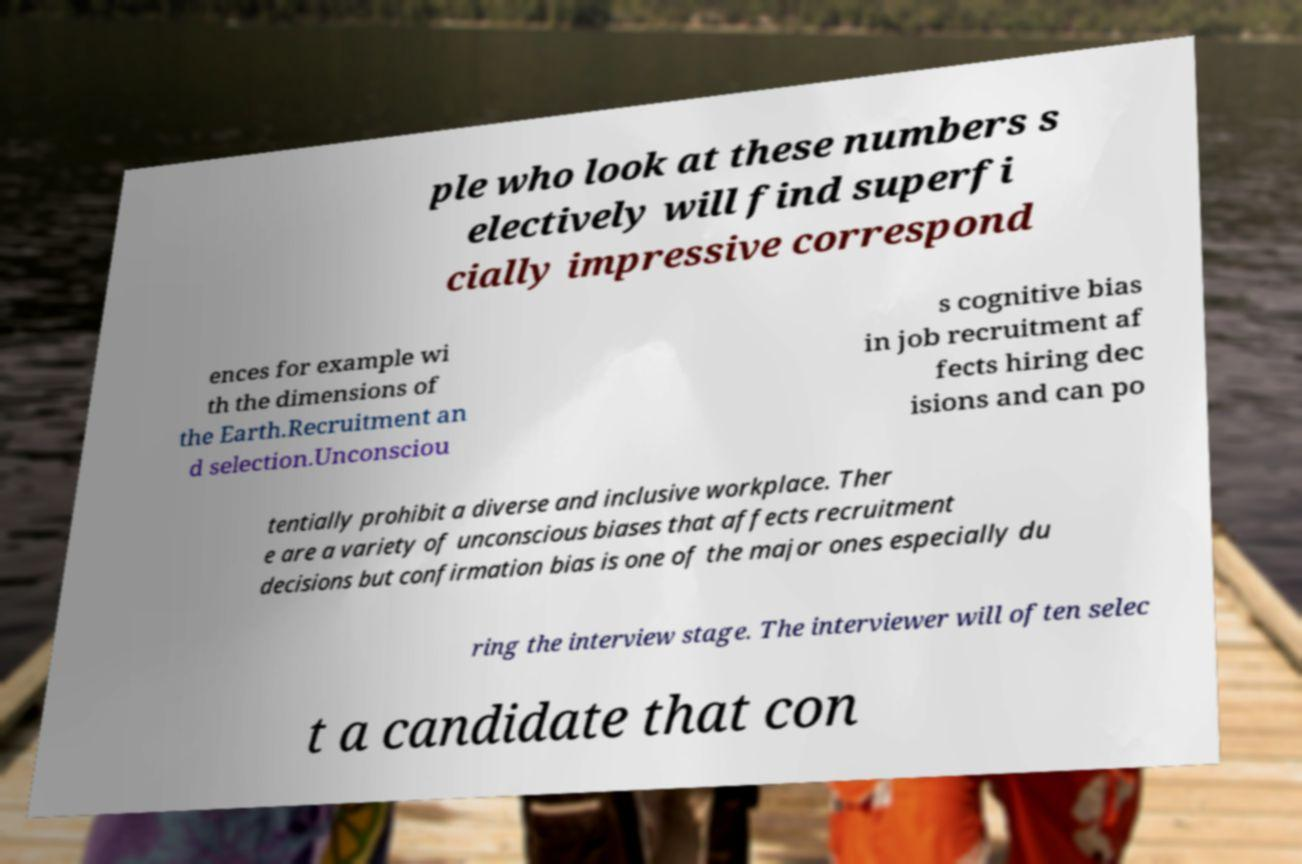Could you assist in decoding the text presented in this image and type it out clearly? ple who look at these numbers s electively will find superfi cially impressive correspond ences for example wi th the dimensions of the Earth.Recruitment an d selection.Unconsciou s cognitive bias in job recruitment af fects hiring dec isions and can po tentially prohibit a diverse and inclusive workplace. Ther e are a variety of unconscious biases that affects recruitment decisions but confirmation bias is one of the major ones especially du ring the interview stage. The interviewer will often selec t a candidate that con 